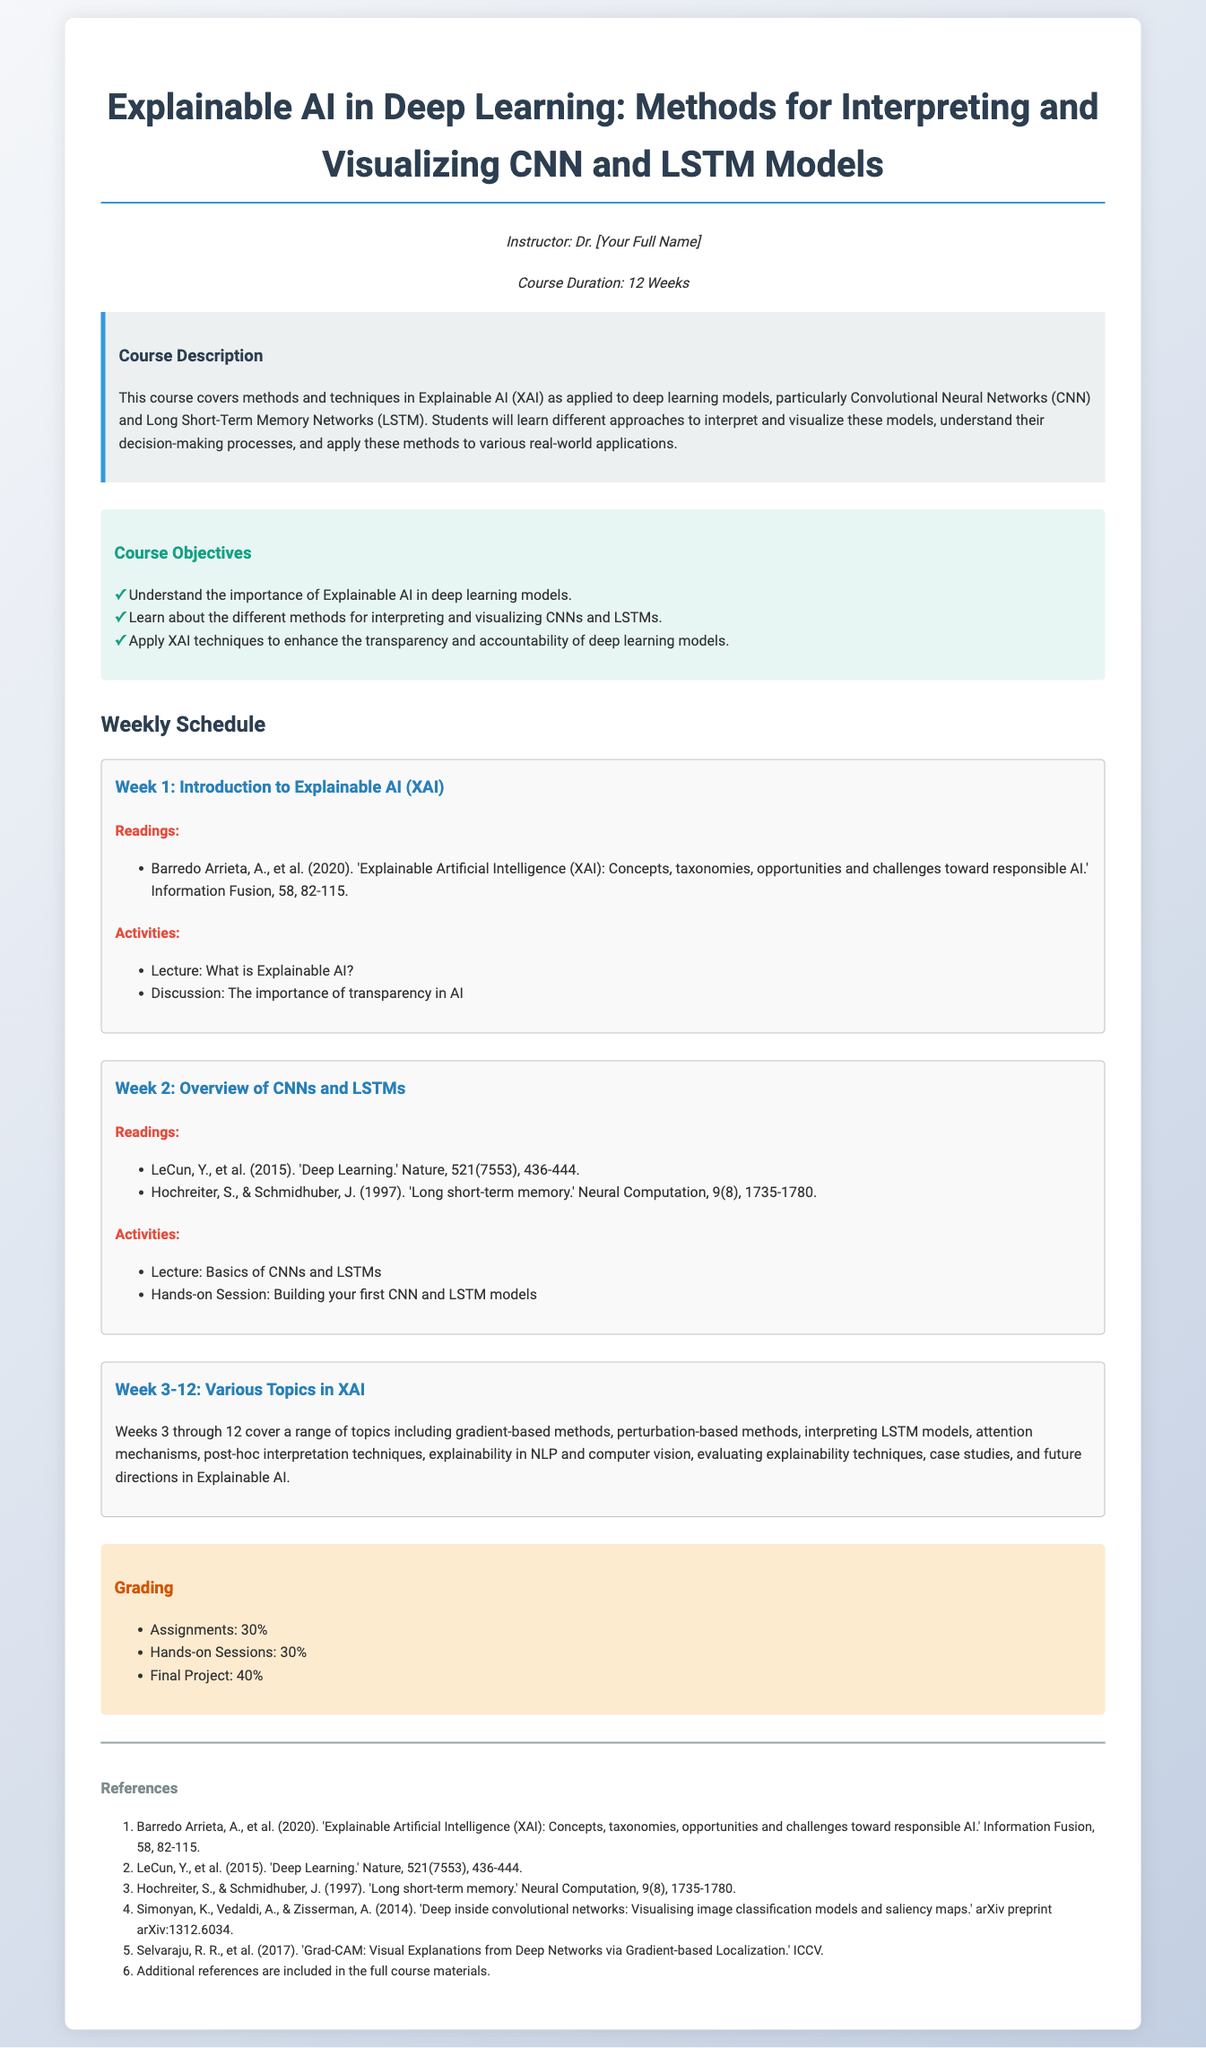What is the title of the course? The title of the course is stated at the beginning of the document.
Answer: Explainable AI in Deep Learning: Methods for Interpreting and Visualizing CNN and LSTM Models Who is the instructor of the course? The name of the instructor is mentioned in the document.
Answer: Dr. [Your Full Name] How long is the course duration? The document specifies the duration of the course clearly.
Answer: 12 Weeks What is the percentage weight of the final project in the grading? The grading section specifies the percentage weight allocated to the final project.
Answer: 40% What is one of the topics covered in Weeks 3-12? The document provides an overview of topics covered in Weeks 3-12.
Answer: gradient-based methods Name one key reading material for Week 1. The readings section for Week 1 includes specific texts that are required.
Answer: Barredo Arrieta, A., et al. (2020). 'Explainable Artificial Intelligence (XAI): Concepts, taxonomies, opportunities and challenges toward responsible AI.' What is one objective of the course? The objectives listed in the course outline highlight key learning goals.
Answer: Understand the importance of Explainable AI in deep learning models What is the focus of the course? The course description outlines the main focus of the curriculum.
Answer: Explainable AI (XAI) as applied to deep learning models 